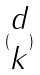Convert formula to latex. <formula><loc_0><loc_0><loc_500><loc_500>( \begin{matrix} d \\ k \end{matrix} )</formula> 